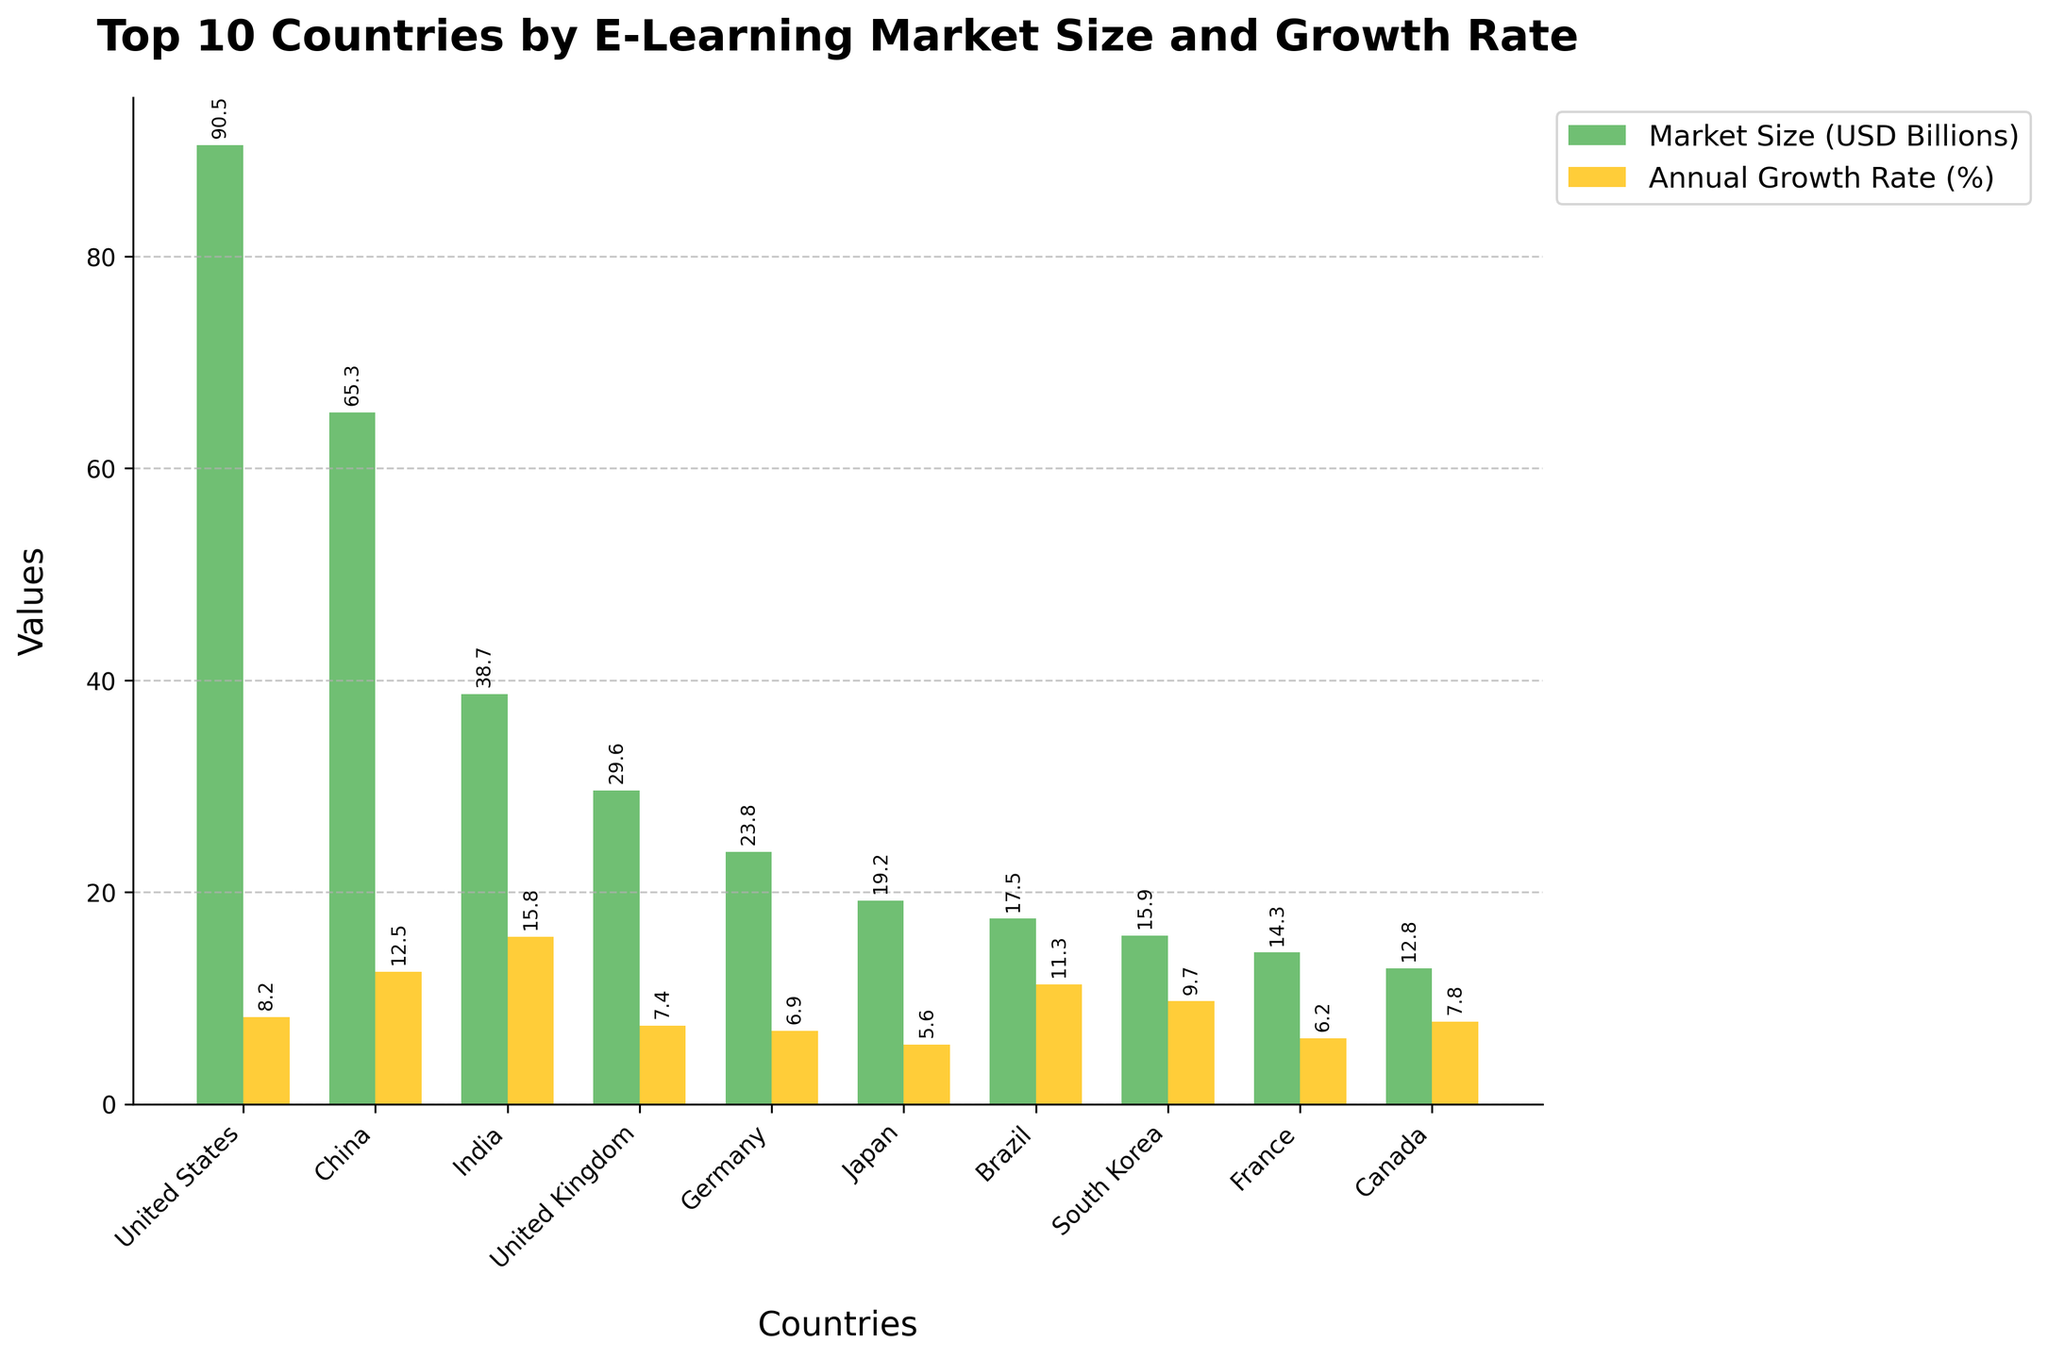Which country has the largest e-learning market size? From the bar chart, the tallest bar representing market size belongs to the United States. Thus, the United States has the largest e-learning market size.
Answer: United States Which country has the highest annual growth rate in the e-learning market? The bar chart's tallest bar representing growth rate belongs to India. Thus, India has the highest annual growth rate for the e-learning market.
Answer: India Compare the e-learning market size of Brazil and South Korea. Which is larger? By comparing the heights of the bars representing market size for Brazil and South Korea, it is evident that the bar for Brazil is taller. Therefore, Brazil has a larger e-learning market size than South Korea.
Answer: Brazil What is the total e-learning market size of the top 3 countries combined? The top 3 countries by market size are the United States (90.5), China (65.3), and India (38.7). Summing these values gives 90.5 + 65.3 + 38.7 = 194.5 USD Billions.
Answer: 194.5 How much more is the e-learning market size in the United States compared to Canada? To find the difference, subtract Canada's market size from the United States' market size: 90.5 - 12.8 = 77.7 USD Billions.
Answer: 77.7 Which countries have an annual growth rate greater than 10%? From the bars representing growth rate, the countries exceeding 10% are China (12.5%), India (15.8%), and Brazil (11.3%).
Answer: China, India, Brazil Compare the annual growth rates of Japan and Germany. Which is higher? By comparing the heights of the growth rate bars for Japan and Germany, it's clear that Germany (6.9%) has a higher growth rate than Japan (5.6%).
Answer: Germany Which country among the top 10 has the smallest e-learning market size? The shortest bar representing market size indicates the country with the smallest market size, which is Canada (12.8 USD Billions).
Answer: Canada If you combine the market sizes of the United Kingdom and France, what is the total? The market sizes for the United Kingdom and France are 29.6 and 14.3, respectively. Summing these values gives 29.6 + 14.3 = 43.9 USD Billions.
Answer: 43.9 Is the annual growth rate of South Korea higher than that of the United Kingdom? By comparing the height of the bars representing the growth rate, South Korea (9.7%) has a higher growth rate than the United Kingdom (7.4%).
Answer: Yes 